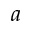Convert formula to latex. <formula><loc_0><loc_0><loc_500><loc_500>a</formula> 